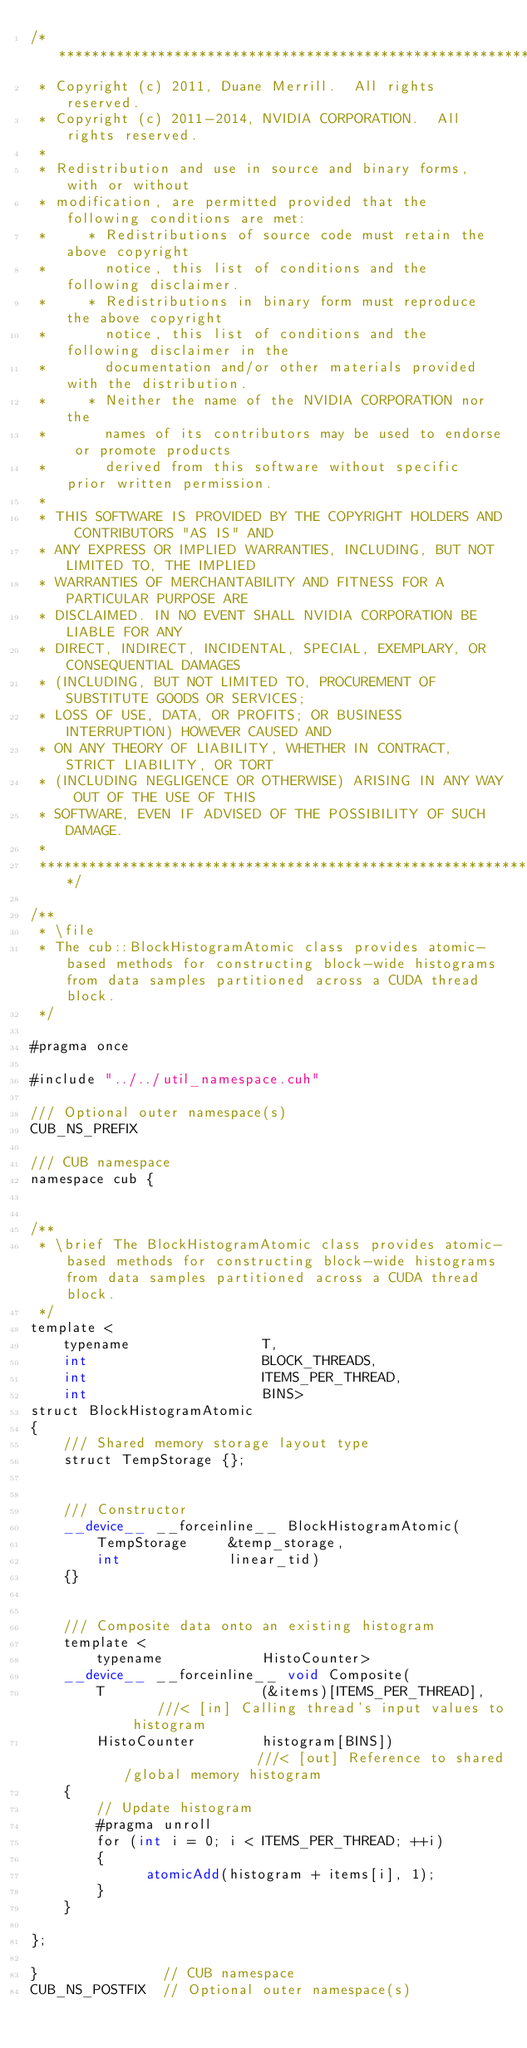<code> <loc_0><loc_0><loc_500><loc_500><_Cuda_>/******************************************************************************
 * Copyright (c) 2011, Duane Merrill.  All rights reserved.
 * Copyright (c) 2011-2014, NVIDIA CORPORATION.  All rights reserved.
 * 
 * Redistribution and use in source and binary forms, with or without
 * modification, are permitted provided that the following conditions are met:
 *     * Redistributions of source code must retain the above copyright
 *       notice, this list of conditions and the following disclaimer.
 *     * Redistributions in binary form must reproduce the above copyright
 *       notice, this list of conditions and the following disclaimer in the
 *       documentation and/or other materials provided with the distribution.
 *     * Neither the name of the NVIDIA CORPORATION nor the
 *       names of its contributors may be used to endorse or promote products
 *       derived from this software without specific prior written permission.
 * 
 * THIS SOFTWARE IS PROVIDED BY THE COPYRIGHT HOLDERS AND CONTRIBUTORS "AS IS" AND
 * ANY EXPRESS OR IMPLIED WARRANTIES, INCLUDING, BUT NOT LIMITED TO, THE IMPLIED
 * WARRANTIES OF MERCHANTABILITY AND FITNESS FOR A PARTICULAR PURPOSE ARE
 * DISCLAIMED. IN NO EVENT SHALL NVIDIA CORPORATION BE LIABLE FOR ANY
 * DIRECT, INDIRECT, INCIDENTAL, SPECIAL, EXEMPLARY, OR CONSEQUENTIAL DAMAGES
 * (INCLUDING, BUT NOT LIMITED TO, PROCUREMENT OF SUBSTITUTE GOODS OR SERVICES;
 * LOSS OF USE, DATA, OR PROFITS; OR BUSINESS INTERRUPTION) HOWEVER CAUSED AND
 * ON ANY THEORY OF LIABILITY, WHETHER IN CONTRACT, STRICT LIABILITY, OR TORT
 * (INCLUDING NEGLIGENCE OR OTHERWISE) ARISING IN ANY WAY OUT OF THE USE OF THIS
 * SOFTWARE, EVEN IF ADVISED OF THE POSSIBILITY OF SUCH DAMAGE.
 *
 ******************************************************************************/

/**
 * \file
 * The cub::BlockHistogramAtomic class provides atomic-based methods for constructing block-wide histograms from data samples partitioned across a CUDA thread block.
 */

#pragma once

#include "../../util_namespace.cuh"

/// Optional outer namespace(s)
CUB_NS_PREFIX

/// CUB namespace
namespace cub {


/**
 * \brief The BlockHistogramAtomic class provides atomic-based methods for constructing block-wide histograms from data samples partitioned across a CUDA thread block.
 */
template <
    typename                T,
    int                     BLOCK_THREADS,
    int                     ITEMS_PER_THREAD,
    int                     BINS>
struct BlockHistogramAtomic
{
    /// Shared memory storage layout type
    struct TempStorage {};


    /// Constructor
    __device__ __forceinline__ BlockHistogramAtomic(
        TempStorage     &temp_storage,
        int             linear_tid)
    {}


    /// Composite data onto an existing histogram
    template <
        typename            HistoCounter>
    __device__ __forceinline__ void Composite(
        T                   (&items)[ITEMS_PER_THREAD],     ///< [in] Calling thread's input values to histogram
        HistoCounter        histogram[BINS])                 ///< [out] Reference to shared/global memory histogram
    {
        // Update histogram
        #pragma unroll
        for (int i = 0; i < ITEMS_PER_THREAD; ++i)
        {
              atomicAdd(histogram + items[i], 1);
        }
    }

};

}               // CUB namespace
CUB_NS_POSTFIX  // Optional outer namespace(s)

</code> 